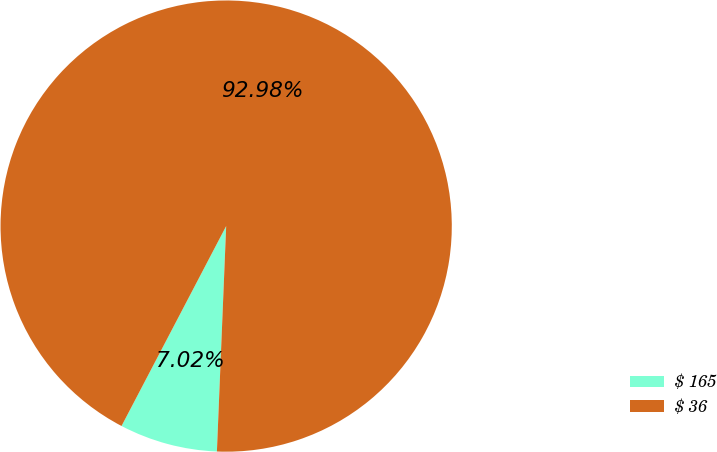Convert chart. <chart><loc_0><loc_0><loc_500><loc_500><pie_chart><fcel>$ 165<fcel>$ 36<nl><fcel>7.02%<fcel>92.98%<nl></chart> 